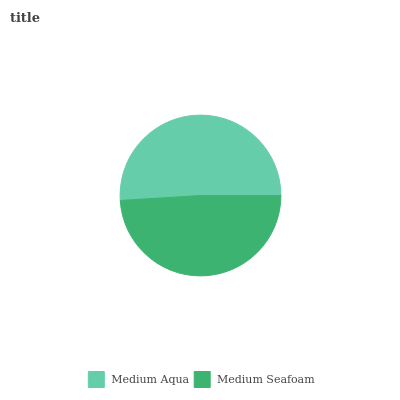Is Medium Seafoam the minimum?
Answer yes or no. Yes. Is Medium Aqua the maximum?
Answer yes or no. Yes. Is Medium Seafoam the maximum?
Answer yes or no. No. Is Medium Aqua greater than Medium Seafoam?
Answer yes or no. Yes. Is Medium Seafoam less than Medium Aqua?
Answer yes or no. Yes. Is Medium Seafoam greater than Medium Aqua?
Answer yes or no. No. Is Medium Aqua less than Medium Seafoam?
Answer yes or no. No. Is Medium Aqua the high median?
Answer yes or no. Yes. Is Medium Seafoam the low median?
Answer yes or no. Yes. Is Medium Seafoam the high median?
Answer yes or no. No. Is Medium Aqua the low median?
Answer yes or no. No. 